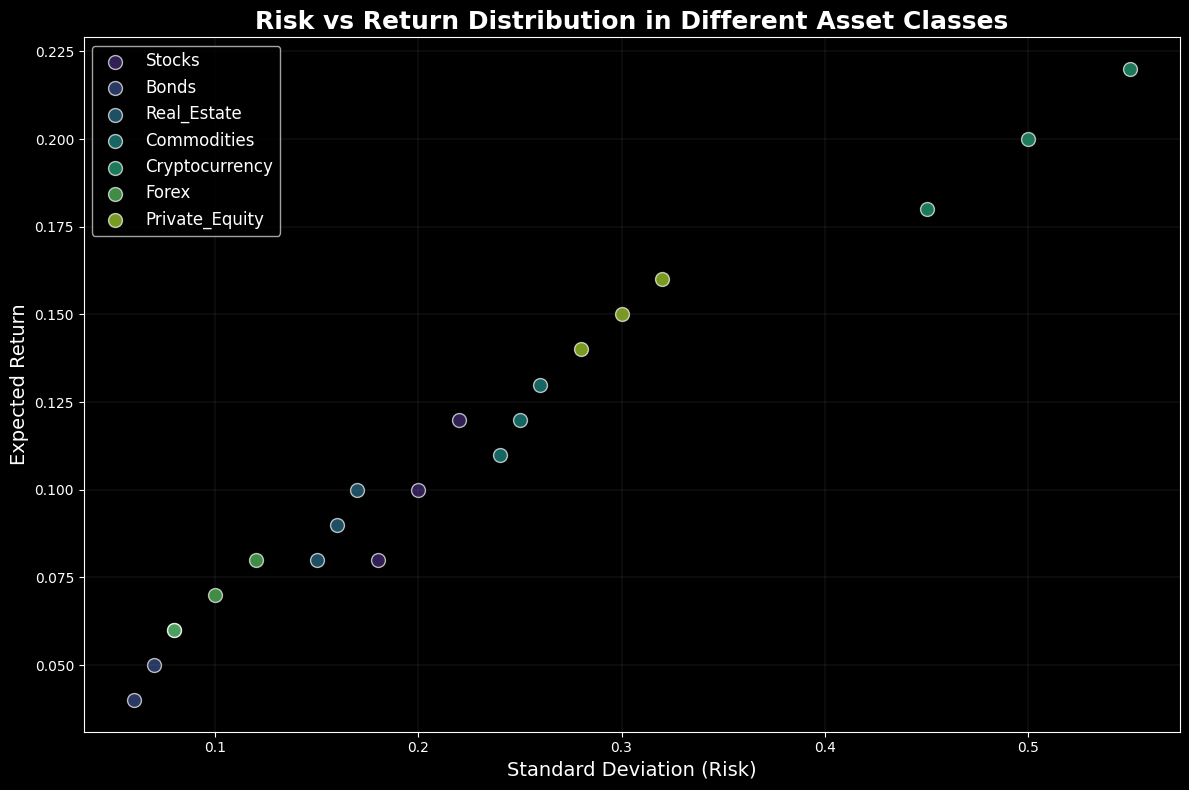What is the asset class with the highest expected return? By visually inspecting the scatter plot, we can see that Cryptocurrency has the highest expected return, which is indicated by the points located at the top of the graph.
Answer: Cryptocurrency Which asset class has the lowest standard deviation? By observing the x-axis (Standard Deviation), it is clear that Bonds has the points closest to the origin, indicating the lowest risk among the asset classes.
Answer: Bonds How do the standard deviations compare between Stocks and Bonds? By comparing the positions of points representing Stocks and Bonds along the x-axis, Stocks points are further to the right than Bonds, indicating higher standard deviation for Stocks.
Answer: Stocks have a higher standard deviation than Bonds Which asset classes fall within an expected return range of 0.05 to 0.10? We can visually identify the points that lie between 0.05 and 0.10 on the y-axis (Expected Return). Bonds, Real Estate, and Forex have points within this range.
Answer: Bonds, Real Estate, Forex Which asset class exhibits the highest risk-return combination? By looking for the highest points along both axes, the Cryptocurrency points are the most to the top right, signifying the highest risk-return combination.
Answer: Cryptocurrency What is the range of expected returns for Private Equity? Private Equity points spread between the expected returns of 0.14 and 0.16 on the y-axis.
Answer: 0.14 to 0.16 Compare the risk (standard deviation) and return of Commodities against Forex. Visually comparing their positions on the scatter plot, Commodities have higher risk (to the right) and higher return (upward) than Forex.
Answer: Commodities have higher risk and return than Forex Which asset class shows the widest spread in expected returns? By observing the vertical dispersion of the points for each class, Cryptocurrency has the widest spread in expected returns, ranging from 0.18 to 0.22.
Answer: Cryptocurrency In terms of average risk (standard deviation), where do Real Estate and Forex stand relative to each other? Calculating the average position along the x-axis for both, Real Estate points appear around 0.16 whereas Forex points appear around 0.10. Thus, Real Estate has a higher average risk than Forex.
Answer: Real Estate has a higher average risk than Forex Which has a tighter clustering in terms of both risk and return: Bonds or Private Equity? Observing the concentration of points, Bonds points are closer together compared to those of Private Equity, which are more spread out both horizontally and vertically.
Answer: Bonds In what ways is the return distribution for Cryptocurrency distinct from that of Bonds? By examining the plot, Cryptocurrency points are significantly higher on the y-axis (return) and more spread out, while Bonds are lower on the y-axis and more tightly clustered.
Answer: Higher returns and more spread out 